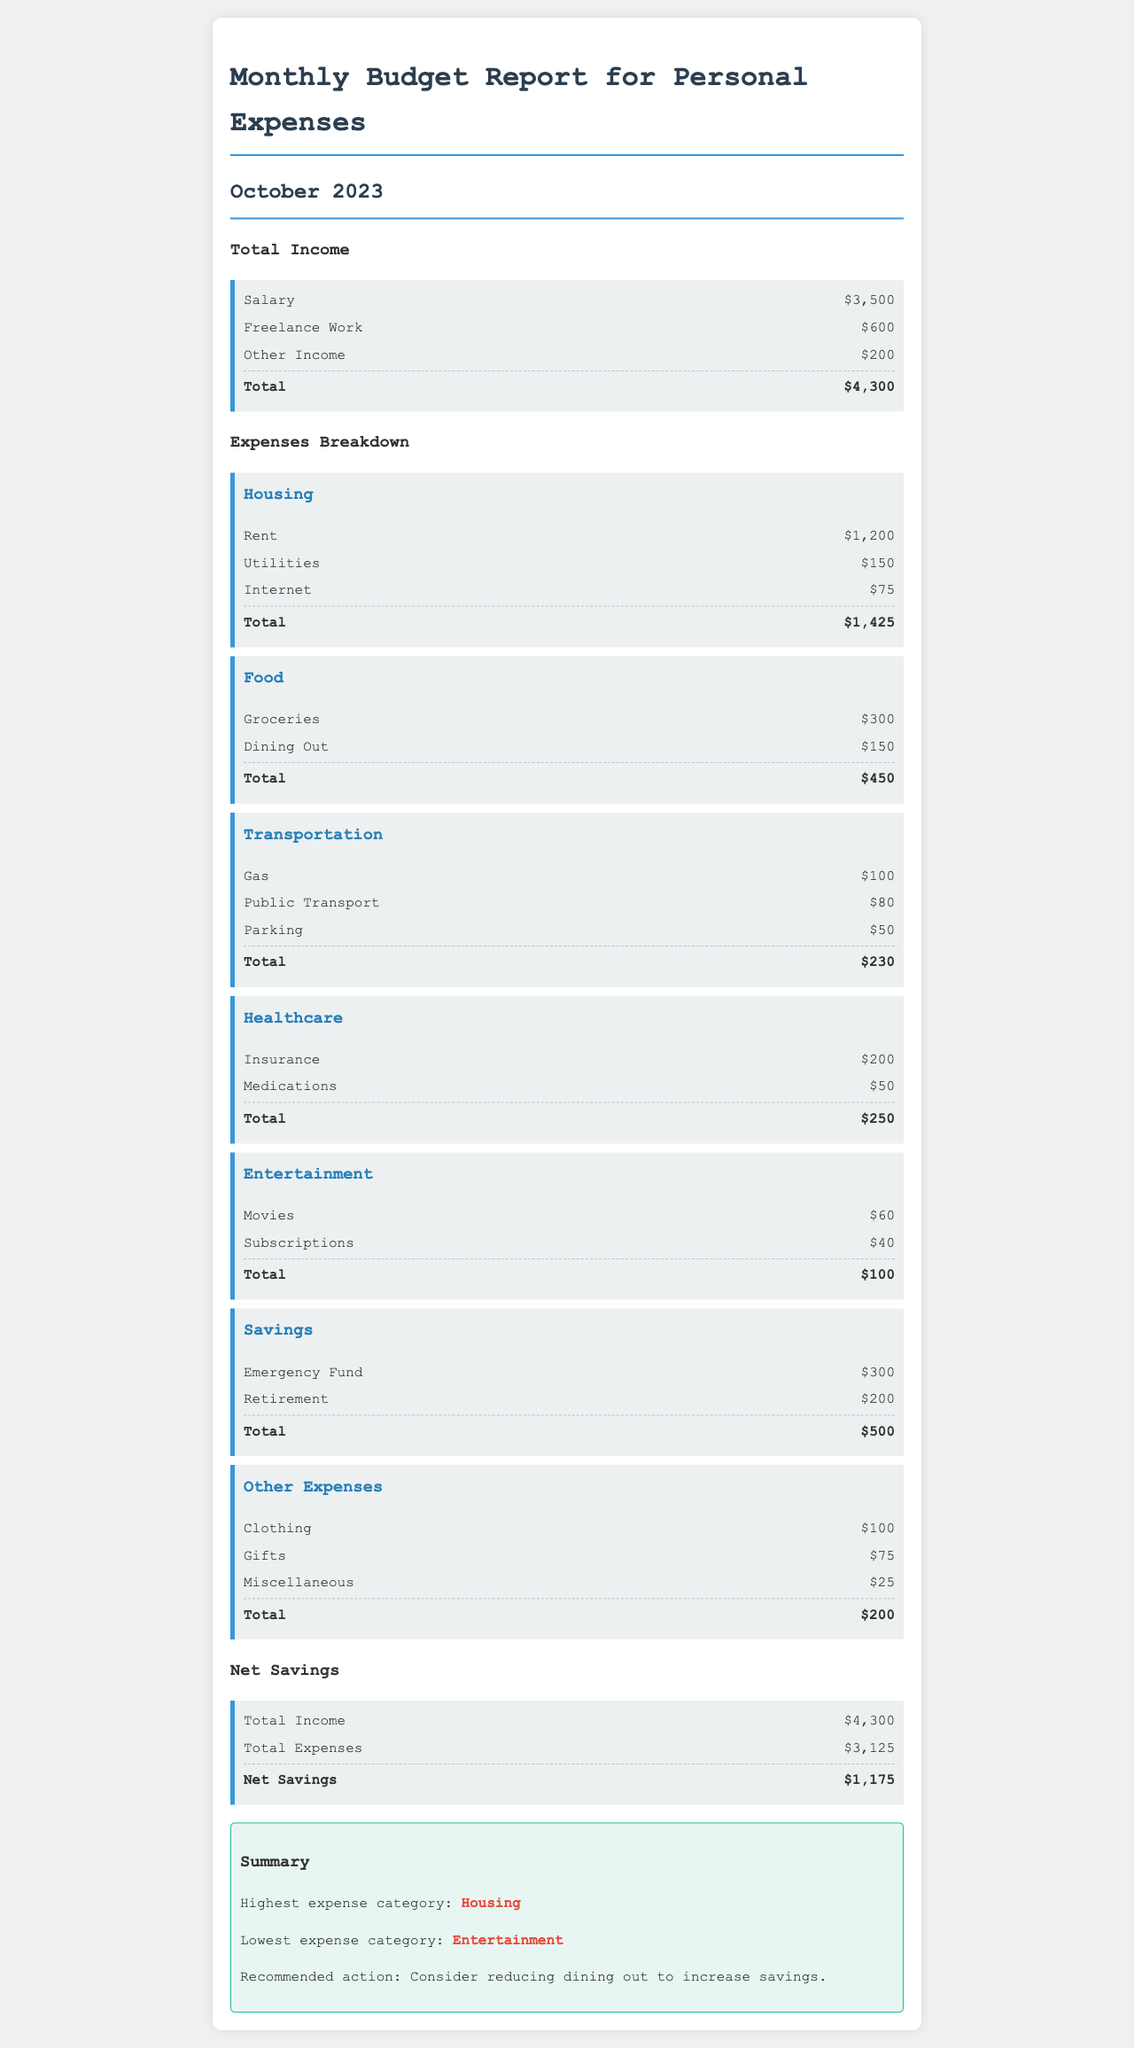What is the total income? The total income is the sum of Salary, Freelance Work, and Other Income listed in the document, which amounts to $3,500 + $600 + $200 = $4,300.
Answer: $4,300 What is the total expense for Housing? The total expenses for Housing include Rent, Utilities, and Internet, totaling $1,200 + $150 + $75 = $1,425.
Answer: $1,425 Which category has the highest total expense? The document indicates that the highest expense category is Housing, with total expenses of $1,425.
Answer: Housing What is the total of the Food expenses? The total of the Food expenses combines Groceries and Dining Out, amounting to $300 + $150 = $450.
Answer: $450 What is the Net Savings for October 2023? The Net Savings is calculated by subtracting Total Expenses from Total Income, resulting in $4,300 - $3,125 = $1,175.
Answer: $1,175 Which expense category is noted as the lowest? The document highlights the lowest expense category, which is Entertainment, with total expenses of $100.
Answer: Entertainment What is the recommended action to increase savings? The document suggests considering reducing dining out as a way to increase savings.
Answer: Reduce dining out What is the total expense for Transportation? The total expenses for Transportation are calculated from Gas, Public Transport, and Parking, totaling $100 + $80 + $50 = $230.
Answer: $230 When was this report created? The report was created for the month of October 2023.
Answer: October 2023 